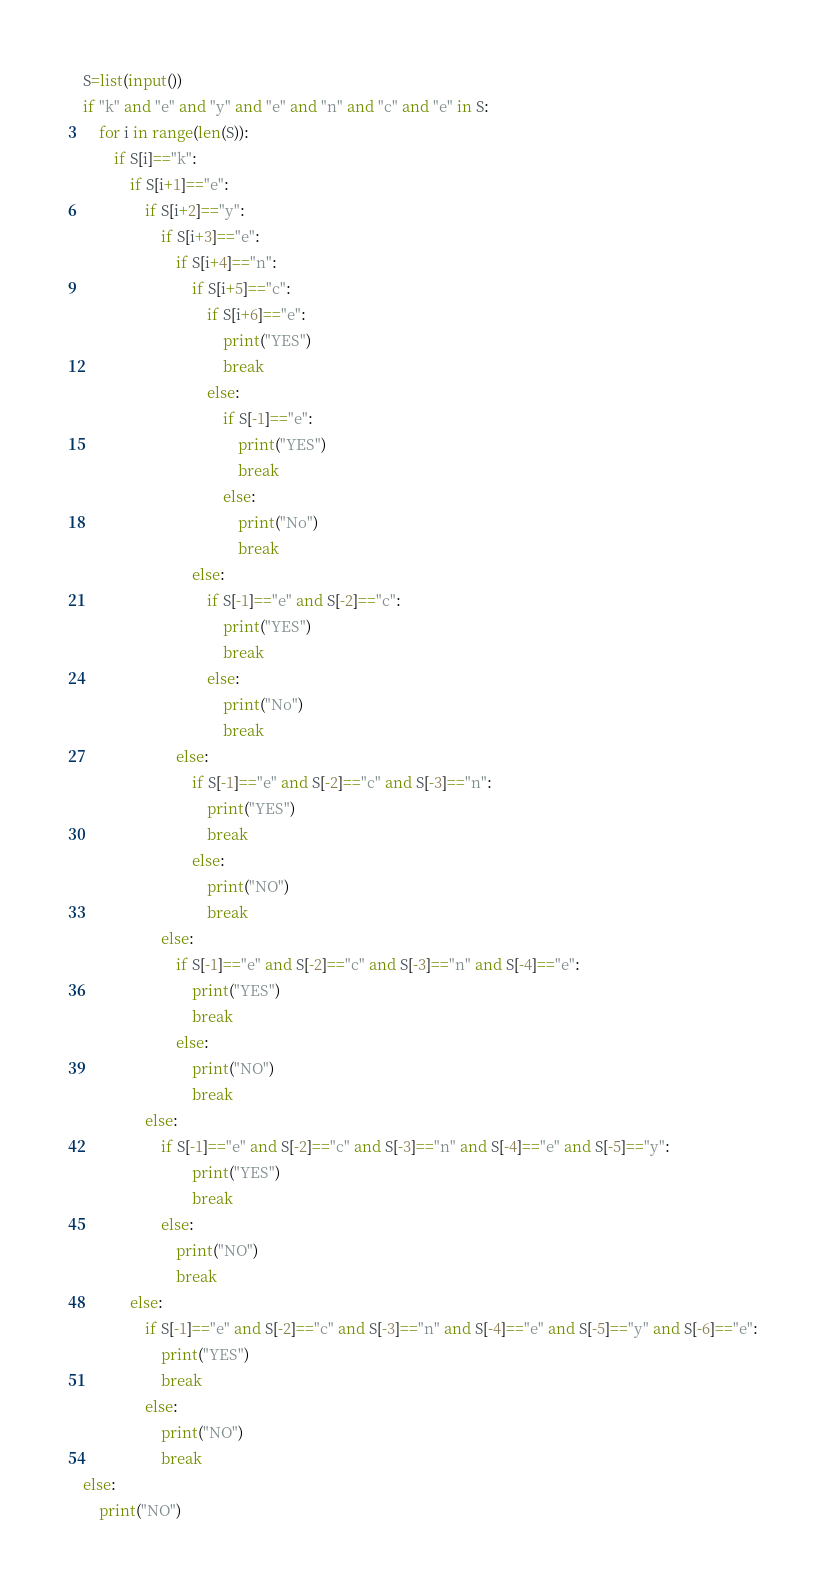<code> <loc_0><loc_0><loc_500><loc_500><_Python_>S=list(input())
if "k" and "e" and "y" and "e" and "n" and "c" and "e" in S:
    for i in range(len(S)):
        if S[i]=="k":
            if S[i+1]=="e":
                if S[i+2]=="y":
                    if S[i+3]=="e":
                        if S[i+4]=="n":
                            if S[i+5]=="c":
                                if S[i+6]=="e":
                                    print("YES")
                                    break
                                else:
                                    if S[-1]=="e":
                                        print("YES")
                                        break
                                    else:
                                        print("No")
                                        break
                            else:
                                if S[-1]=="e" and S[-2]=="c":
                                    print("YES")
                                    break
                                else:
                                    print("No")
                                    break
                        else:
                            if S[-1]=="e" and S[-2]=="c" and S[-3]=="n":
                                print("YES")
                                break
                            else:
                                print("NO")
                                break
                    else:
                        if S[-1]=="e" and S[-2]=="c" and S[-3]=="n" and S[-4]=="e":
                            print("YES")
                            break
                        else:
                            print("NO")
                            break
                else:
                    if S[-1]=="e" and S[-2]=="c" and S[-3]=="n" and S[-4]=="e" and S[-5]=="y":
                            print("YES")
                            break
                    else:
                        print("NO")
                        break
            else:
                if S[-1]=="e" and S[-2]=="c" and S[-3]=="n" and S[-4]=="e" and S[-5]=="y" and S[-6]=="e":
                    print("YES")
                    break
                else:
                    print("NO")
                    break
else:
    print("NO")</code> 